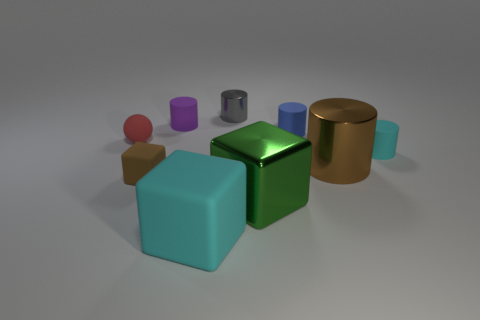Subtract all blue cylinders. How many cylinders are left? 4 Subtract all tiny cyan cylinders. How many cylinders are left? 4 Add 1 tiny yellow matte objects. How many objects exist? 10 Subtract all yellow cylinders. Subtract all purple balls. How many cylinders are left? 5 Subtract all blocks. How many objects are left? 6 Add 6 small brown shiny spheres. How many small brown shiny spheres exist? 6 Subtract 0 red cylinders. How many objects are left? 9 Subtract all big cyan blocks. Subtract all small shiny things. How many objects are left? 7 Add 7 shiny things. How many shiny things are left? 10 